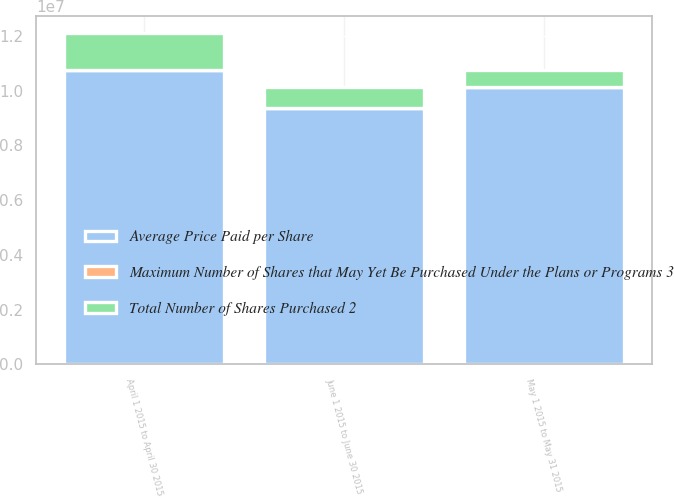Convert chart to OTSL. <chart><loc_0><loc_0><loc_500><loc_500><stacked_bar_chart><ecel><fcel>April 1 2015 to April 30 2015<fcel>May 1 2015 to May 31 2015<fcel>June 1 2015 to June 30 2015<nl><fcel>Total Number of Shares Purchased 2<fcel>1.35009e+06<fcel>634622<fcel>764301<nl><fcel>Maximum Number of Shares that May Yet Be Purchased Under the Plans or Programs 3<fcel>58.93<fcel>59.31<fcel>57.26<nl><fcel>Average Price Paid per Share<fcel>1.07603e+07<fcel>1.01257e+07<fcel>9.36141e+06<nl></chart> 